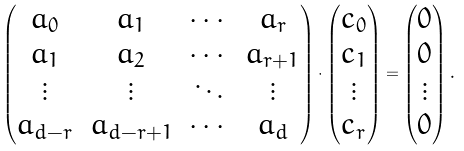Convert formula to latex. <formula><loc_0><loc_0><loc_500><loc_500>\begin{pmatrix} a _ { 0 } & a _ { 1 } & \cdots & a _ { r } \\ a _ { 1 } & a _ { 2 } & \cdots & a _ { r + 1 } \\ \vdots & \vdots & \ddots & \vdots \\ a _ { d - r } & a _ { d - r + 1 } & \cdots & a _ { d } \end{pmatrix} \cdot \begin{pmatrix} c _ { 0 } \\ c _ { 1 } \\ \vdots \\ c _ { r } \end{pmatrix} = \begin{pmatrix} 0 \\ 0 \\ \vdots \\ 0 \end{pmatrix} .</formula> 